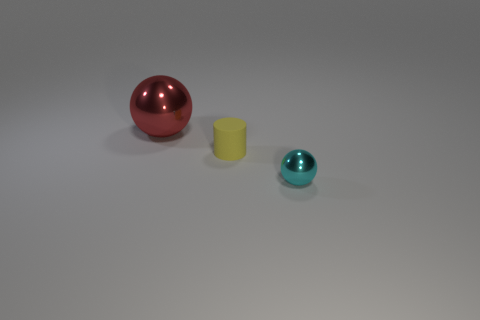What might be the material of these objects? The red and cyan objects bear a reflective surface, suggesting they could be made of a polished or glossy material, such as plastic or painted wood. The yellow cylinder appears to have a matte finish, which could mean it is made of a different material, potentially uncoated plastic or another non-reflective substance. 